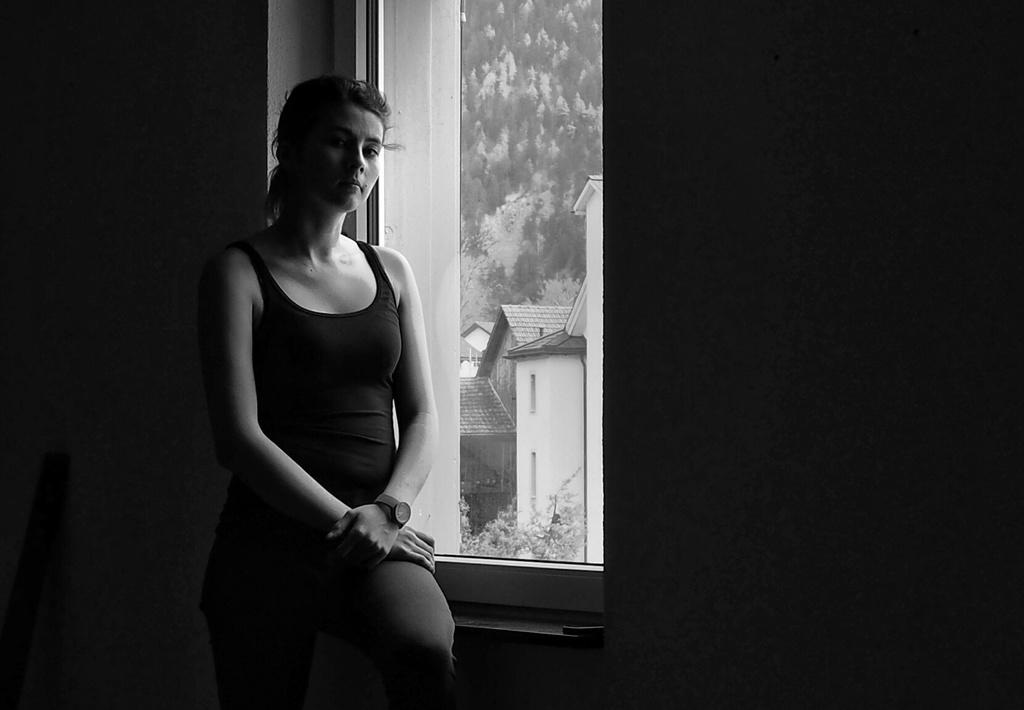What is the color scheme of the image? The image is black and white. What is the woman in the image doing? The woman is sitting near the window. What accessory is the woman wearing? The woman is wearing a watch. What can be seen outside the window in the image? Houses and trees are visible behind the window. How many snails are crawling on the woman's watch in the image? There are no snails visible in the image, so it is not possible to determine how many might be on the woman's watch. 